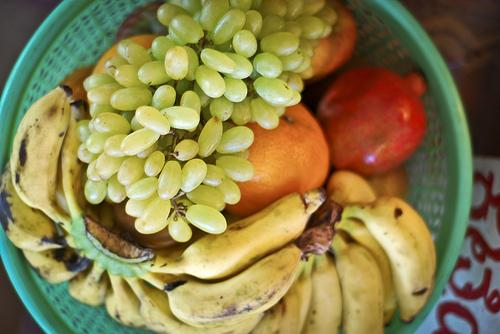Using a poetic language, describe the scene in the image with a focus on the fruit composition. A luscious collection of vibrant fruits - sweet bananas, verdant grapes, radiant orange, and vivid red pomegranate - nestle together in a green, circular cradle. Analyze the context: Are these fruits ready to be consumed and where do you think this photo may have been taken? The fruits seem ripe and ready for consumption, and the photo might have been taken in a kitchen or a dining room setting. Mention any anomalies in the image by using formal language. Upon stringent examination, one can discern a few inconsistencies, such as a dark discoloration on the banana, the presence of holes in the basket, and a light reflection on the fruit.  Briefly describe any complex reasoning involved in analyzing the composition of the image. The analysis of the image entails associating the given information with relevant visual elements, comprehending the arrangement of various fruits in the basket, and discerning imperfections amidst the intricate presentation of colorful and ripe fruits. Mention the color and shape of the basket that contains the fruits. The basket is green and circular in shape. Do a VQA task: What is the material of the basket and what type of fruit appears to be the most abundant? The basket is made of green plastic, and bananas seem to be the most abundant fruit. What are the noticeable imperfections or flaws in the image? Mention at least three. Dark discoloration on the banana, holes in the side of the basket, and light reflection on the fruit. Perform an image sentiment analysis: How does the display of this image make the viewer feel?  The image evokes a sentiment of freshness, abundance, and wellbeing due to the variety of colorful and ripe fruits in the basket. Imagine you have a close-up view of the grapes. How can you describe their appearance? The grapes are a fresh, bright shade of green with plump and round bodies, connected by a stem that extends into the heart of the bunch. List all the different types of fruit in the bowl, as well as their respective colors. There are two bunches of yellow bananas, green grapes, a round red apple, a red pomegranate, and a round orange. Did you see the blue grapes in the basket? No, it's not mentioned in the image. Take a look at the pear in the fruit bowl. There is no mention of a pear in the list of fruits described in the bowl. There is a yellow pomegranate in the basket. The pomegranate is described as red, not yellow, and it is not mentioned as any other color. The orange in the basket has a square shape. The orange is described as round, not square, and there are no other mentions of differently shaped oranges. The plastic basket has smooth sides with no holes. The basket is described as having holes in its side, not smooth, solid sides. The bananas in the bowl are unripe and green. The bananas are mentioned as yellow or overripe, not green and unripe. Is the basket holding the fruit a red metal structure? The container holding the fruit is described as being a green plastic basket, not a red metal one. Notice how the bananas in the basket are large and plump. The bananas are described as small, not large and plump. 